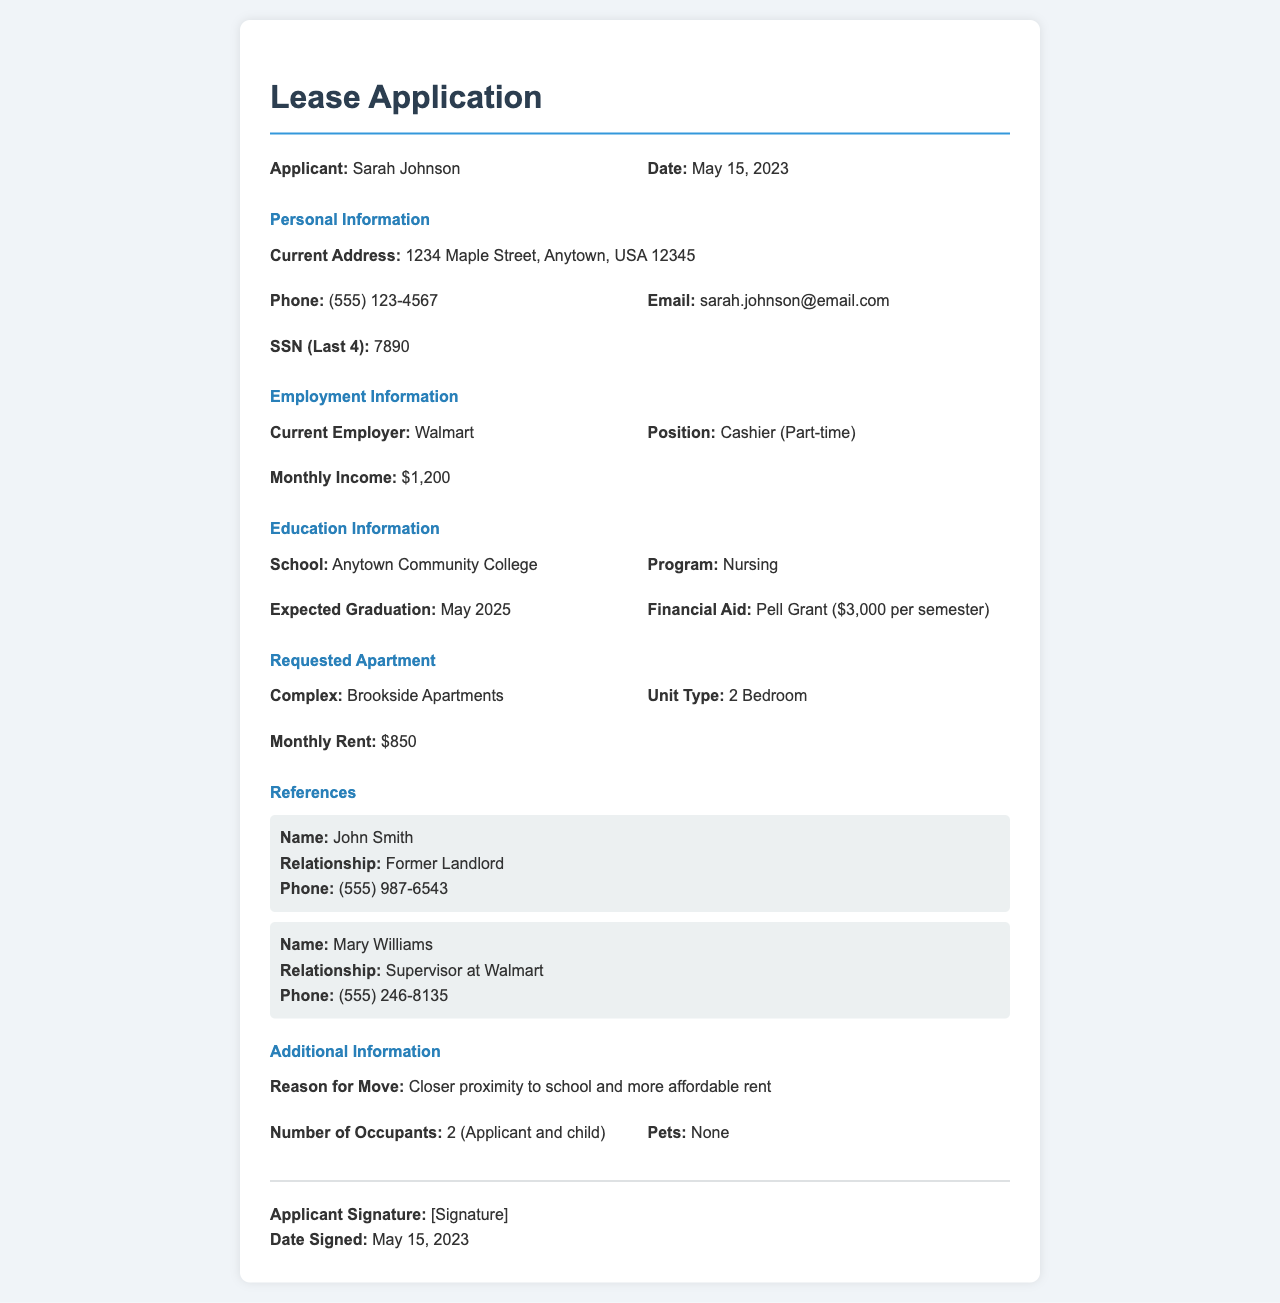What is the applicant's name? The applicant's name is prominently displayed at the top of the document.
Answer: Sarah Johnson What is the date of the application? The date is located next to the applicant's name and is important for processing the application.
Answer: May 15, 2023 What is the applicant's current employer? The applicant's current employment details are summarized in the Employment Information section.
Answer: Walmart What is the monthly rent for the requested apartment? The requested apartment's rent is mentioned in the Requested Apartment section of the document.
Answer: $850 What is the expected graduation date of the applicant? This date is provided in the Education Information section and indicates the timeline for the applicant's studies.
Answer: May 2025 Who is the applicant's supervisor at Walmart? This information is found in the References section, which lists people who can vouch for the applicant.
Answer: Mary Williams How many occupants will be in the apartment? The number of occupants is mentioned in the Additional Information section.
Answer: 2 What is the applicant's reason for moving? The reason for the move is detailed in the Additional Information section and indicates their motivation for applying.
Answer: Closer proximity to school and more affordable rent 